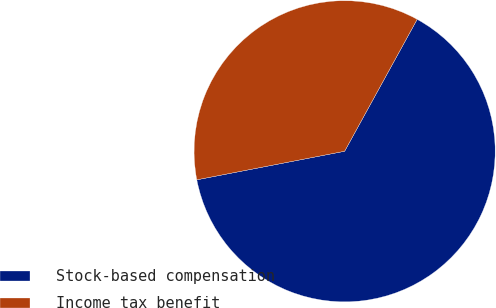<chart> <loc_0><loc_0><loc_500><loc_500><pie_chart><fcel>Stock-based compensation<fcel>Income tax benefit<nl><fcel>63.96%<fcel>36.04%<nl></chart> 